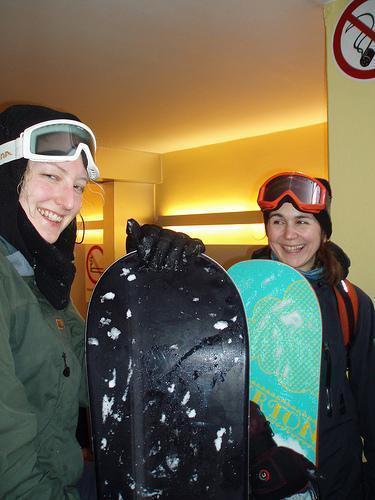How many people appear in this picture?
Give a very brief answer. 2. How many people are wearing goggles in this photo?
Give a very brief answer. 2. How many people are holding snowboards?
Give a very brief answer. 2. 